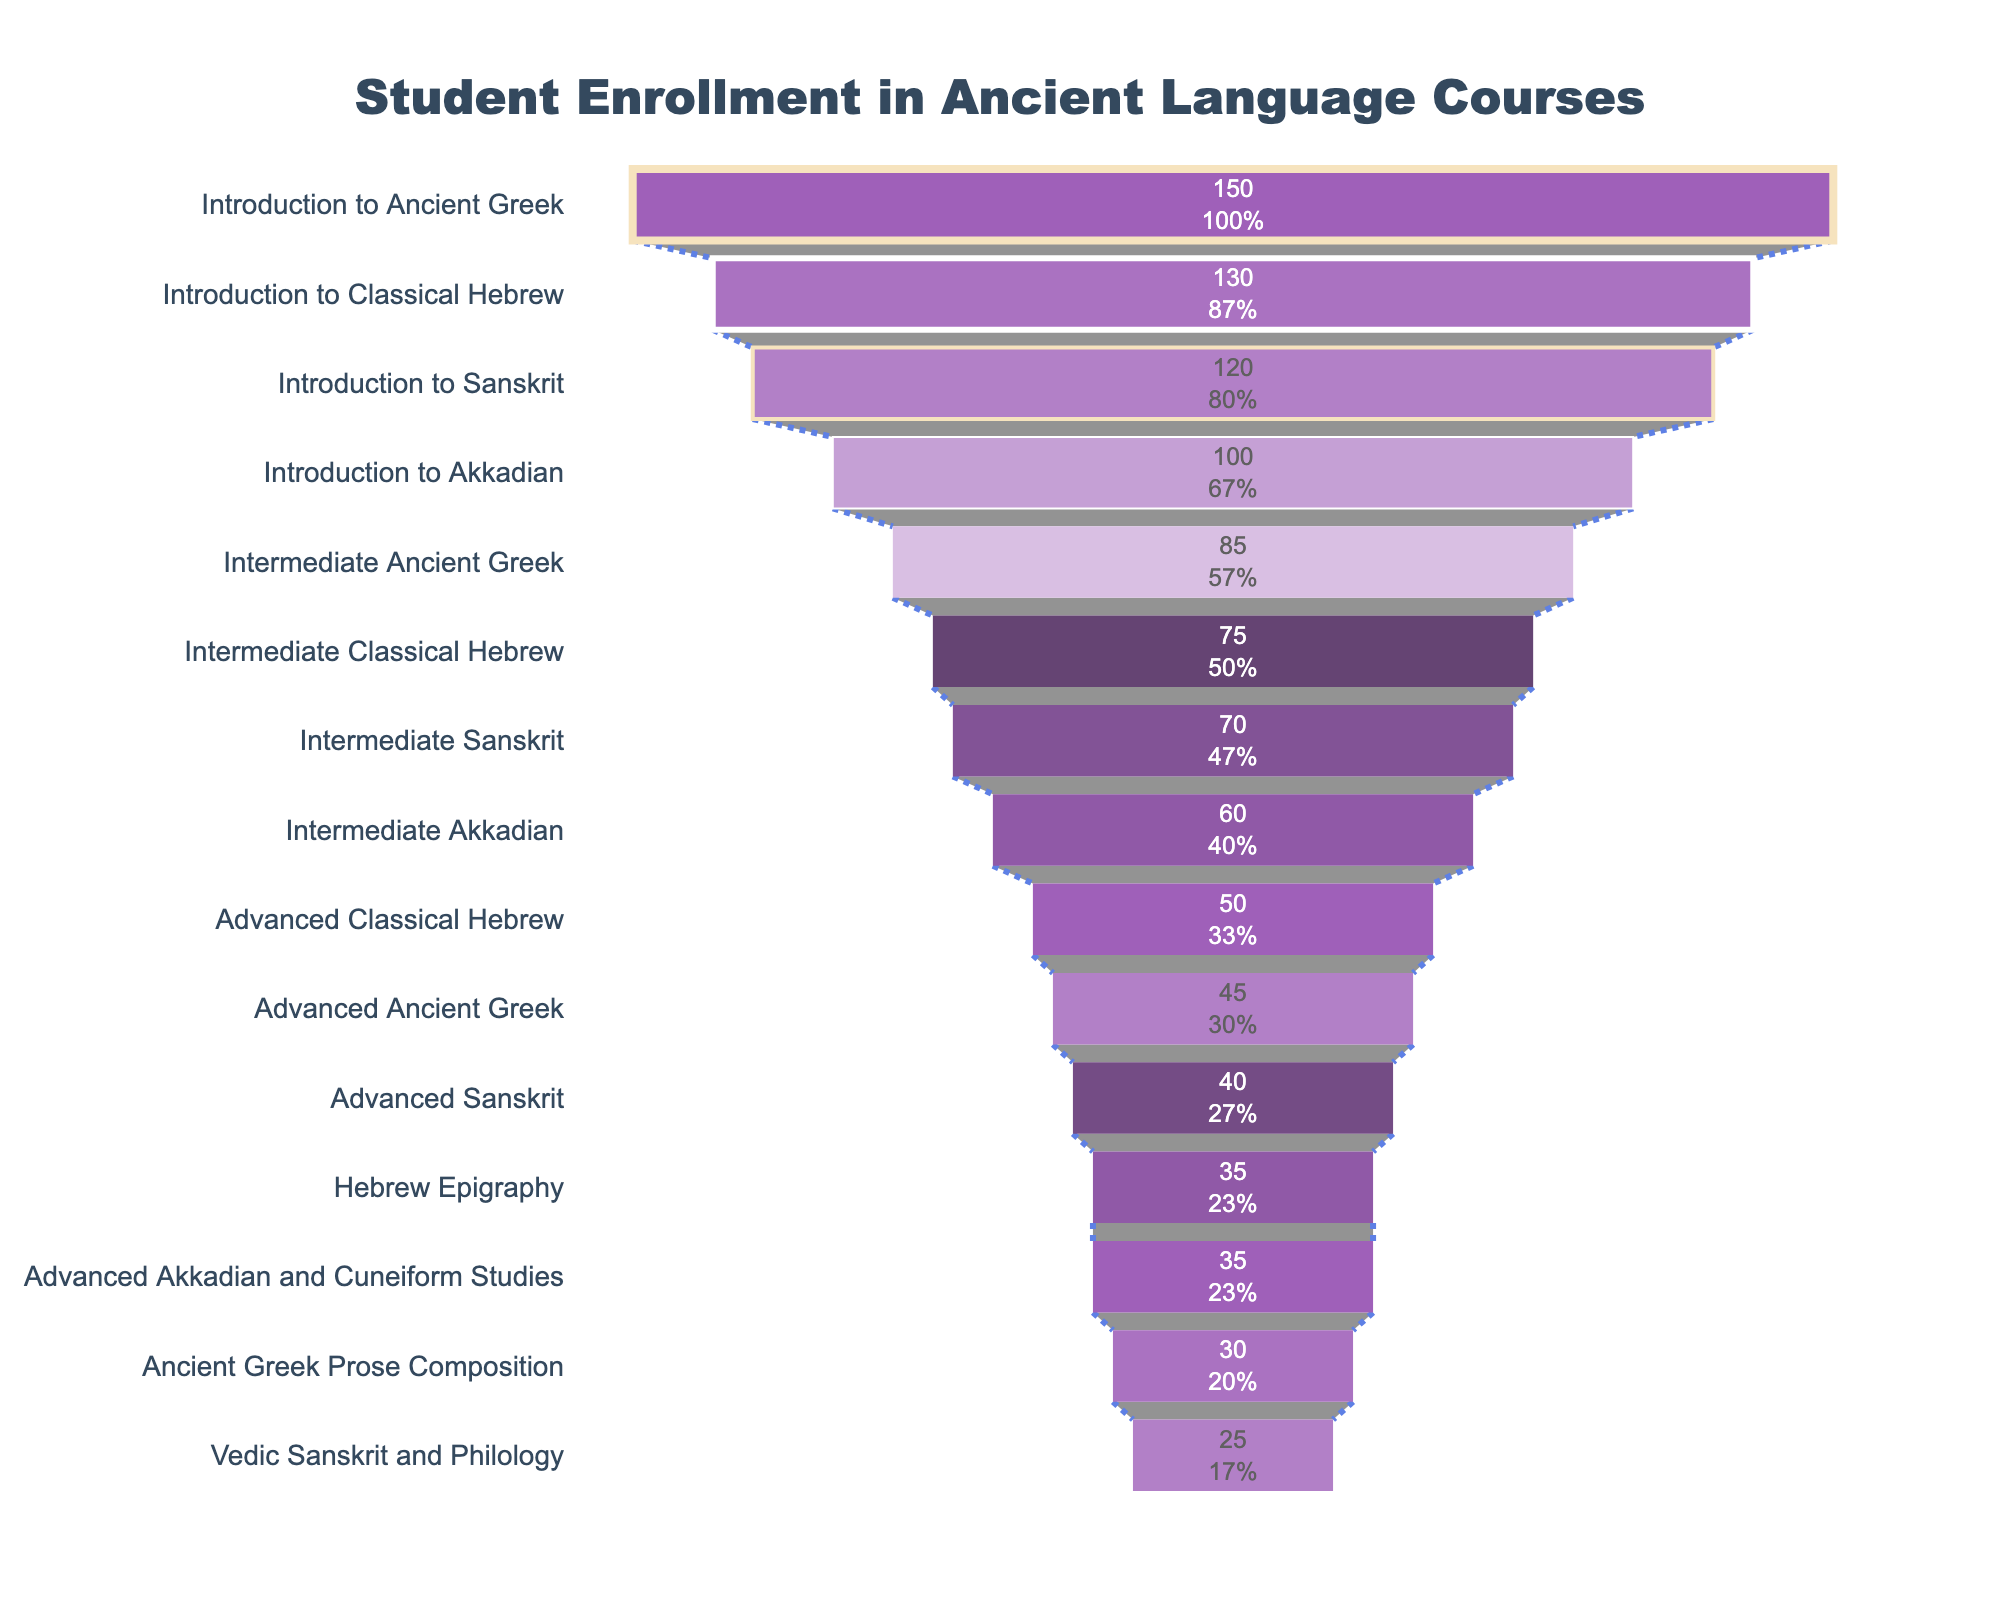How many courses have an enrollment of fewer than 50 students? Look at the visual indication of enrollments on the funnel chart. Identify the courses with enrollments listed at or below 50. Count these courses.
Answer: 8 Which course has the highest enrollment? Identify the course at the top of the funnel in the chart, which corresponds to the highest enrollment value.
Answer: Introduction to Ancient Greek What is the total enrollment for all advanced courses combined? Identify all courses labeled as "Advanced" in the chart. Note their enrollment numbers and sum them: Advanced Ancient Greek (45) + Advanced Sanskrit (40) + Advanced Classical Hebrew (50) + Advanced Akkadian and Cuneiform Studies (35). Add these numbers together.
Answer: 170 Compare the enrollment in Introduction to Classical Hebrew to that in Introduction to Akkadian. Which is higher? Find the enrollment figures for Introduction to Classical Hebrew and Introduction to Akkadian from the chart. Compare these numbers: Introduction to Classical Hebrew (130) vs. Introduction to Akkadian (100).
Answer: Introduction to Classical Hebrew What percentage of the total enrollment does Intermediate Sanskrit represent? Sum all enrollments to get the total: 150 + 85 + 45 + 30 + 120 + 70 + 40 + 25 + 130 + 75 + 50 + 35 + 100 + 60 + 35 = 1023. Divide the enrollment of Intermediate Sanskrit (70) by the total and multiply by 100 to get the percentage: (70 / 1023) * 100.
Answer: ~6.84% Which has more students: Intermediate Ancient Greek or Intermediate Akkadian? Compare the enrollment values of Intermediate Ancient Greek (85) and Intermediate Akkadian (60) directly from the chart.
Answer: Intermediate Ancient Greek How many courses have an enrollment rate between 30 and 100 students? Identify the courses within the enrollment range of 30 to 100: Intermediate Ancient Greek, Advanced Ancient Greek, Ancient Greek Prose Composition, Intermediate Sanskrit, Advanced Sanskrit, Introduction to Akkadian, Intermediate Akkadian, Advanced Akkadian and Cuneiform Studies. Count these courses.
Answer: 8 Is the enrollment in Intermediate Classical Hebrew more or less than the enrollment in Advanced Classical Hebrew? By how much? Compare the enrollment values of Intermediate Classical Hebrew (75) and Advanced Classical Hebrew (50). Calculate the difference by subtracting the smaller value from the larger value: 75 - 50.
Answer: 25 more What is the ratio of the enrollment in Introduction to Sanskrit to that in Vedic Sanskrit and Philology? Identify the enrollments for Introduction to Sanskrit (120) and Vedic Sanskrit and Philology (25). Divide the former by the latter to get their ratio: 120 / 25.
Answer: 4.8 Which advanced-level course has the lowest enrollment? Look at the funnel segments representing advanced-level courses and identify the one with the lowest enrollment: Advanced Ancient Greek (45), Advanced Sanskrit (40), Advanced Classical Hebrew (50), Advanced Akkadian and Cuneiform Studies (35). The one with the lowest number is Advanced Akkadian and Cuneiform Studies.
Answer: Advanced Akkadian and Cuneiform Studies 